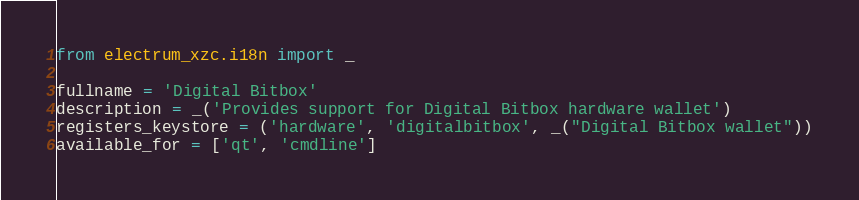<code> <loc_0><loc_0><loc_500><loc_500><_Python_>from electrum_xzc.i18n import _

fullname = 'Digital Bitbox'
description = _('Provides support for Digital Bitbox hardware wallet')
registers_keystore = ('hardware', 'digitalbitbox', _("Digital Bitbox wallet"))
available_for = ['qt', 'cmdline']
</code> 